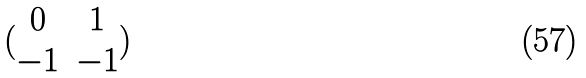<formula> <loc_0><loc_0><loc_500><loc_500>( \begin{matrix} 0 & 1 \\ - 1 & - 1 \end{matrix} )</formula> 